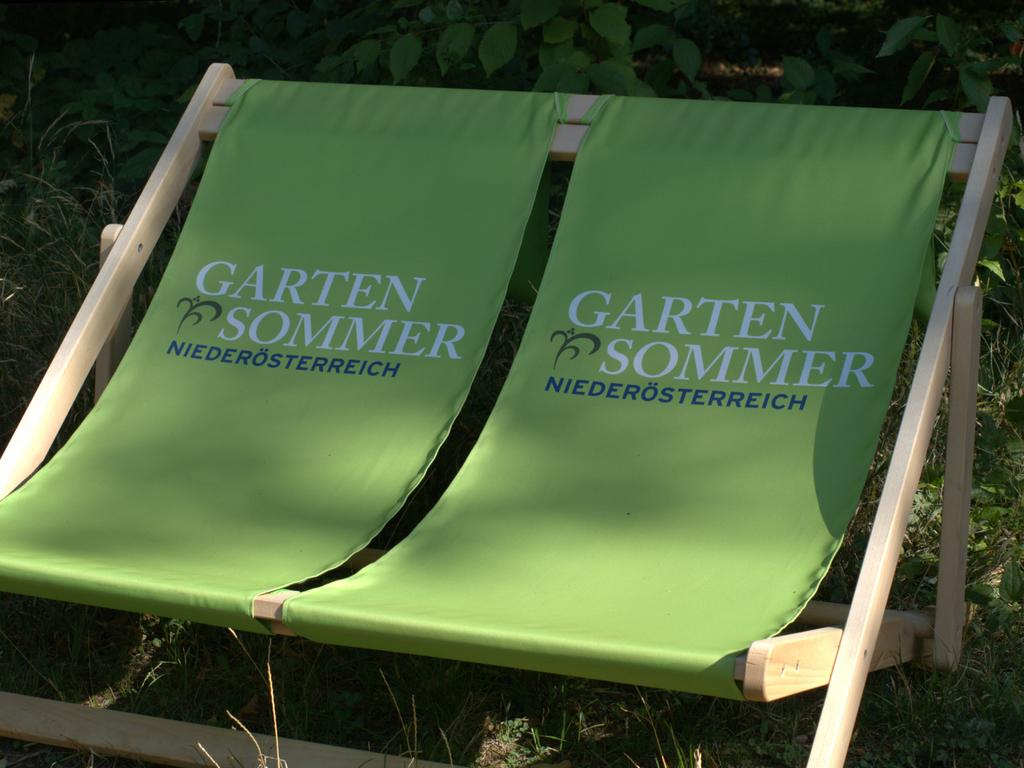What type of seating is present in the image? There are green benches in the image. What can be seen in the background of the image? There are plants and grass in the background of the image. What part of the plants is visible at the top of the image? Leaves are visible at the top of the image. How many babies are crawling on the green benches in the image? There are no babies present in the image; it only features green benches, plants, grass, and leaves. 